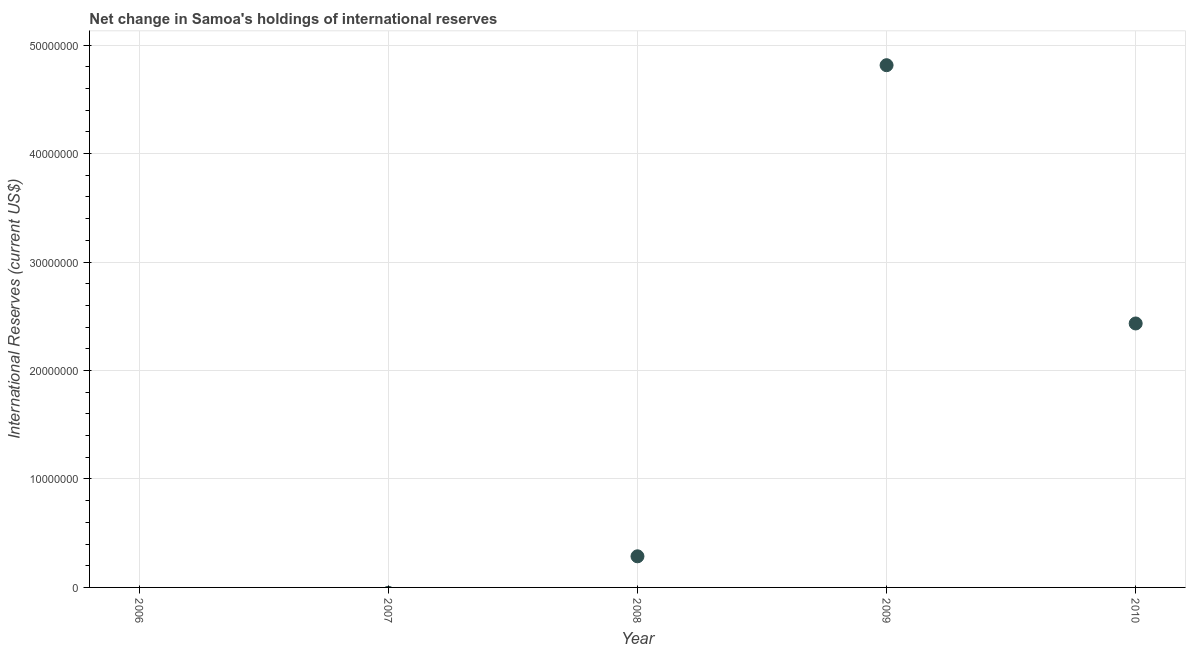Across all years, what is the maximum reserves and related items?
Provide a short and direct response. 4.82e+07. What is the sum of the reserves and related items?
Provide a succinct answer. 7.54e+07. What is the difference between the reserves and related items in 2009 and 2010?
Your response must be concise. 2.38e+07. What is the average reserves and related items per year?
Your response must be concise. 1.51e+07. What is the median reserves and related items?
Your answer should be very brief. 2.87e+06. In how many years, is the reserves and related items greater than 8000000 US$?
Provide a short and direct response. 2. What is the ratio of the reserves and related items in 2008 to that in 2010?
Your answer should be very brief. 0.12. Is the difference between the reserves and related items in 2008 and 2010 greater than the difference between any two years?
Offer a very short reply. No. What is the difference between the highest and the second highest reserves and related items?
Offer a very short reply. 2.38e+07. What is the difference between the highest and the lowest reserves and related items?
Give a very brief answer. 4.82e+07. Does the reserves and related items monotonically increase over the years?
Your answer should be very brief. No. Are the values on the major ticks of Y-axis written in scientific E-notation?
Your answer should be compact. No. What is the title of the graph?
Give a very brief answer. Net change in Samoa's holdings of international reserves. What is the label or title of the Y-axis?
Make the answer very short. International Reserves (current US$). What is the International Reserves (current US$) in 2006?
Ensure brevity in your answer.  0. What is the International Reserves (current US$) in 2007?
Offer a terse response. 0. What is the International Reserves (current US$) in 2008?
Provide a short and direct response. 2.87e+06. What is the International Reserves (current US$) in 2009?
Offer a very short reply. 4.82e+07. What is the International Reserves (current US$) in 2010?
Offer a terse response. 2.43e+07. What is the difference between the International Reserves (current US$) in 2008 and 2009?
Your response must be concise. -4.53e+07. What is the difference between the International Reserves (current US$) in 2008 and 2010?
Your answer should be compact. -2.15e+07. What is the difference between the International Reserves (current US$) in 2009 and 2010?
Keep it short and to the point. 2.38e+07. What is the ratio of the International Reserves (current US$) in 2008 to that in 2009?
Your answer should be very brief. 0.06. What is the ratio of the International Reserves (current US$) in 2008 to that in 2010?
Provide a succinct answer. 0.12. What is the ratio of the International Reserves (current US$) in 2009 to that in 2010?
Provide a short and direct response. 1.98. 